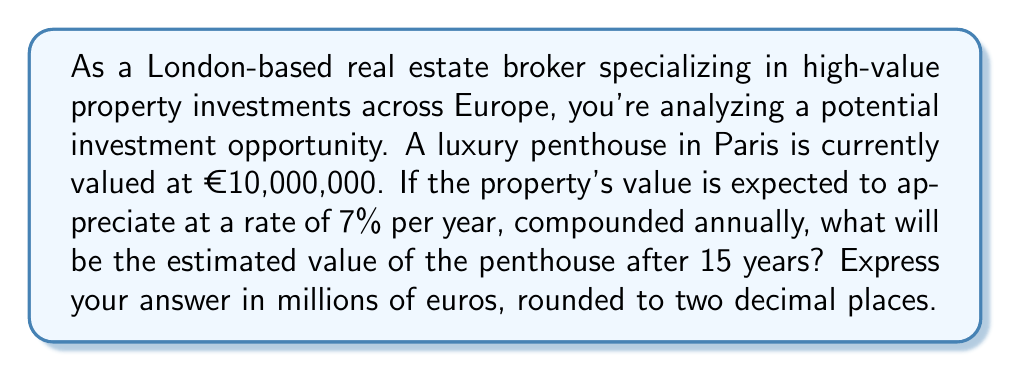Show me your answer to this math problem. To solve this problem, we'll use the compound interest formula:

$$A = P(1 + r)^t$$

Where:
$A$ = Final amount
$P$ = Principal (initial investment)
$r$ = Annual interest rate (as a decimal)
$t$ = Time in years

Given:
$P = €10,000,000$
$r = 7\% = 0.07$
$t = 15$ years

Let's substitute these values into the formula:

$$A = 10,000,000(1 + 0.07)^{15}$$

Now, let's calculate step by step:

1) First, calculate $(1 + 0.07)^{15}$:
   $$(1.07)^{15} = 2.7590190083$$

2) Multiply this by the initial value:
   $$10,000,000 \times 2.7590190083 = 27,590,190.083$$

3) The result is in euros. To express it in millions of euros, divide by 1,000,000:
   $$27,590,190.083 \div 1,000,000 = 27.590190083$$

4) Rounding to two decimal places:
   $$27.59$$ million euros

Therefore, after 15 years, the estimated value of the penthouse will be €27.59 million.
Answer: €27.59 million 